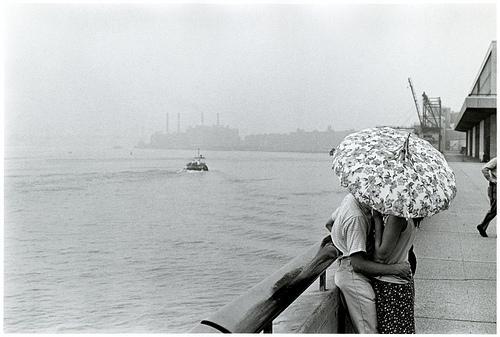What are these two people doing?
Short answer required. Kissing. Why is there an umbrella covering the couple?
Be succinct. Privacy. Which woman is closer?
Concise answer only. One under umbrella. Is there a boat on the water?
Give a very brief answer. Yes. 